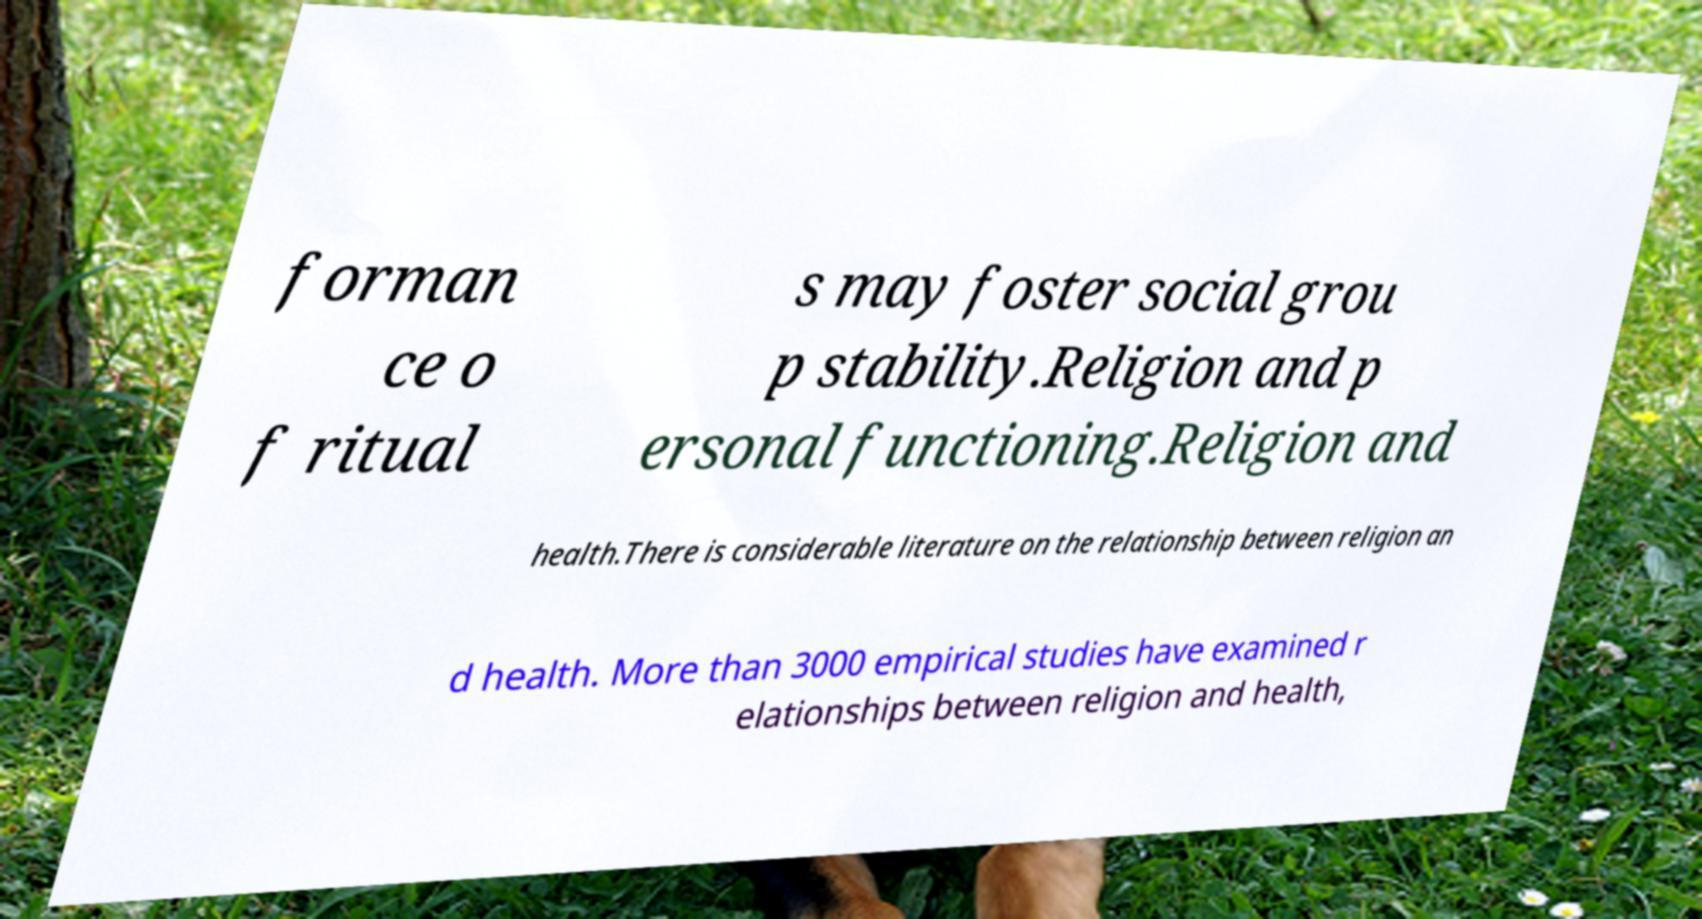I need the written content from this picture converted into text. Can you do that? forman ce o f ritual s may foster social grou p stability.Religion and p ersonal functioning.Religion and health.There is considerable literature on the relationship between religion an d health. More than 3000 empirical studies have examined r elationships between religion and health, 